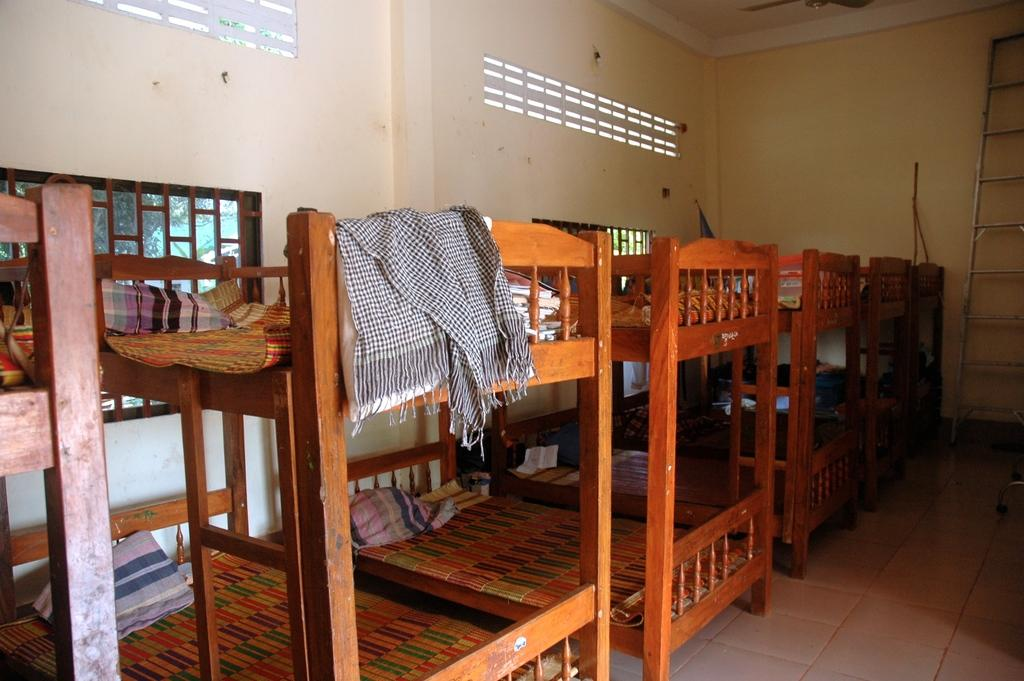What type of furniture is on the floor in the image? There are wooden beds on the floor. What can be seen in the background of the image? There are walls in the background. What is above the beds in the image? There is a ceiling visible in the image. What appliance is present in the image? There is a fan in the image. What is beside the bed that might be used for reaching higher areas? There is a ladder beside the bed. What type of tree can be seen growing through the wooden bed in the image? There is no tree growing through the wooden bed in the image; it is a wooden bed on the floor. How many ducks are visible on the ladder in the image? There are no ducks present in the image, and therefore no ducks can be seen on the ladder. 